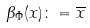Convert formula to latex. <formula><loc_0><loc_0><loc_500><loc_500>\beta _ { \Phi } ( x ) \colon = \overline { x }</formula> 